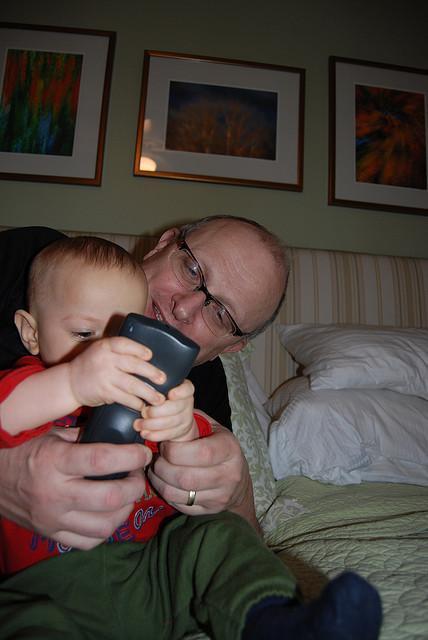How many remotes are visible?
Give a very brief answer. 1. How many people are there?
Give a very brief answer. 2. How many bear arms are raised to the bears' ears?
Give a very brief answer. 0. 